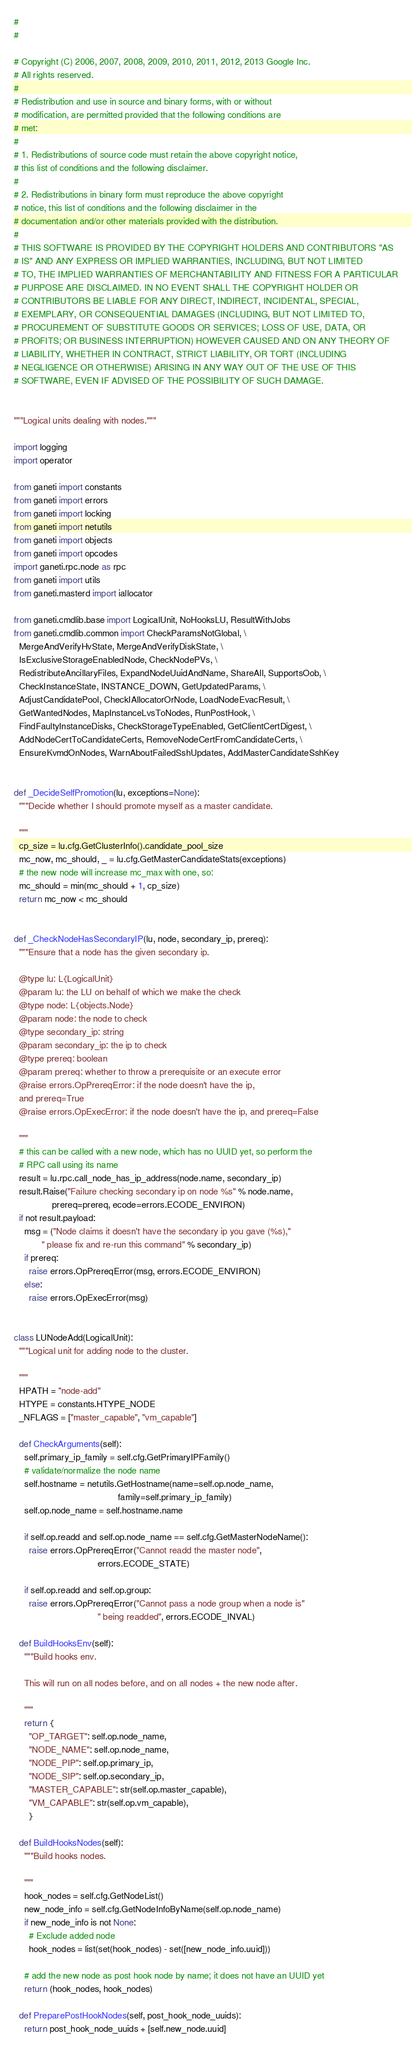<code> <loc_0><loc_0><loc_500><loc_500><_Python_>#
#

# Copyright (C) 2006, 2007, 2008, 2009, 2010, 2011, 2012, 2013 Google Inc.
# All rights reserved.
#
# Redistribution and use in source and binary forms, with or without
# modification, are permitted provided that the following conditions are
# met:
#
# 1. Redistributions of source code must retain the above copyright notice,
# this list of conditions and the following disclaimer.
#
# 2. Redistributions in binary form must reproduce the above copyright
# notice, this list of conditions and the following disclaimer in the
# documentation and/or other materials provided with the distribution.
#
# THIS SOFTWARE IS PROVIDED BY THE COPYRIGHT HOLDERS AND CONTRIBUTORS "AS
# IS" AND ANY EXPRESS OR IMPLIED WARRANTIES, INCLUDING, BUT NOT LIMITED
# TO, THE IMPLIED WARRANTIES OF MERCHANTABILITY AND FITNESS FOR A PARTICULAR
# PURPOSE ARE DISCLAIMED. IN NO EVENT SHALL THE COPYRIGHT HOLDER OR
# CONTRIBUTORS BE LIABLE FOR ANY DIRECT, INDIRECT, INCIDENTAL, SPECIAL,
# EXEMPLARY, OR CONSEQUENTIAL DAMAGES (INCLUDING, BUT NOT LIMITED TO,
# PROCUREMENT OF SUBSTITUTE GOODS OR SERVICES; LOSS OF USE, DATA, OR
# PROFITS; OR BUSINESS INTERRUPTION) HOWEVER CAUSED AND ON ANY THEORY OF
# LIABILITY, WHETHER IN CONTRACT, STRICT LIABILITY, OR TORT (INCLUDING
# NEGLIGENCE OR OTHERWISE) ARISING IN ANY WAY OUT OF THE USE OF THIS
# SOFTWARE, EVEN IF ADVISED OF THE POSSIBILITY OF SUCH DAMAGE.


"""Logical units dealing with nodes."""

import logging
import operator

from ganeti import constants
from ganeti import errors
from ganeti import locking
from ganeti import netutils
from ganeti import objects
from ganeti import opcodes
import ganeti.rpc.node as rpc
from ganeti import utils
from ganeti.masterd import iallocator

from ganeti.cmdlib.base import LogicalUnit, NoHooksLU, ResultWithJobs
from ganeti.cmdlib.common import CheckParamsNotGlobal, \
  MergeAndVerifyHvState, MergeAndVerifyDiskState, \
  IsExclusiveStorageEnabledNode, CheckNodePVs, \
  RedistributeAncillaryFiles, ExpandNodeUuidAndName, ShareAll, SupportsOob, \
  CheckInstanceState, INSTANCE_DOWN, GetUpdatedParams, \
  AdjustCandidatePool, CheckIAllocatorOrNode, LoadNodeEvacResult, \
  GetWantedNodes, MapInstanceLvsToNodes, RunPostHook, \
  FindFaultyInstanceDisks, CheckStorageTypeEnabled, GetClientCertDigest, \
  AddNodeCertToCandidateCerts, RemoveNodeCertFromCandidateCerts, \
  EnsureKvmdOnNodes, WarnAboutFailedSshUpdates, AddMasterCandidateSshKey


def _DecideSelfPromotion(lu, exceptions=None):
  """Decide whether I should promote myself as a master candidate.

  """
  cp_size = lu.cfg.GetClusterInfo().candidate_pool_size
  mc_now, mc_should, _ = lu.cfg.GetMasterCandidateStats(exceptions)
  # the new node will increase mc_max with one, so:
  mc_should = min(mc_should + 1, cp_size)
  return mc_now < mc_should


def _CheckNodeHasSecondaryIP(lu, node, secondary_ip, prereq):
  """Ensure that a node has the given secondary ip.

  @type lu: L{LogicalUnit}
  @param lu: the LU on behalf of which we make the check
  @type node: L{objects.Node}
  @param node: the node to check
  @type secondary_ip: string
  @param secondary_ip: the ip to check
  @type prereq: boolean
  @param prereq: whether to throw a prerequisite or an execute error
  @raise errors.OpPrereqError: if the node doesn't have the ip,
  and prereq=True
  @raise errors.OpExecError: if the node doesn't have the ip, and prereq=False

  """
  # this can be called with a new node, which has no UUID yet, so perform the
  # RPC call using its name
  result = lu.rpc.call_node_has_ip_address(node.name, secondary_ip)
  result.Raise("Failure checking secondary ip on node %s" % node.name,
               prereq=prereq, ecode=errors.ECODE_ENVIRON)
  if not result.payload:
    msg = ("Node claims it doesn't have the secondary ip you gave (%s),"
           " please fix and re-run this command" % secondary_ip)
    if prereq:
      raise errors.OpPrereqError(msg, errors.ECODE_ENVIRON)
    else:
      raise errors.OpExecError(msg)


class LUNodeAdd(LogicalUnit):
  """Logical unit for adding node to the cluster.

  """
  HPATH = "node-add"
  HTYPE = constants.HTYPE_NODE
  _NFLAGS = ["master_capable", "vm_capable"]

  def CheckArguments(self):
    self.primary_ip_family = self.cfg.GetPrimaryIPFamily()
    # validate/normalize the node name
    self.hostname = netutils.GetHostname(name=self.op.node_name,
                                         family=self.primary_ip_family)
    self.op.node_name = self.hostname.name

    if self.op.readd and self.op.node_name == self.cfg.GetMasterNodeName():
      raise errors.OpPrereqError("Cannot readd the master node",
                                 errors.ECODE_STATE)

    if self.op.readd and self.op.group:
      raise errors.OpPrereqError("Cannot pass a node group when a node is"
                                 " being readded", errors.ECODE_INVAL)

  def BuildHooksEnv(self):
    """Build hooks env.

    This will run on all nodes before, and on all nodes + the new node after.

    """
    return {
      "OP_TARGET": self.op.node_name,
      "NODE_NAME": self.op.node_name,
      "NODE_PIP": self.op.primary_ip,
      "NODE_SIP": self.op.secondary_ip,
      "MASTER_CAPABLE": str(self.op.master_capable),
      "VM_CAPABLE": str(self.op.vm_capable),
      }

  def BuildHooksNodes(self):
    """Build hooks nodes.

    """
    hook_nodes = self.cfg.GetNodeList()
    new_node_info = self.cfg.GetNodeInfoByName(self.op.node_name)
    if new_node_info is not None:
      # Exclude added node
      hook_nodes = list(set(hook_nodes) - set([new_node_info.uuid]))

    # add the new node as post hook node by name; it does not have an UUID yet
    return (hook_nodes, hook_nodes)

  def PreparePostHookNodes(self, post_hook_node_uuids):
    return post_hook_node_uuids + [self.new_node.uuid]
</code> 